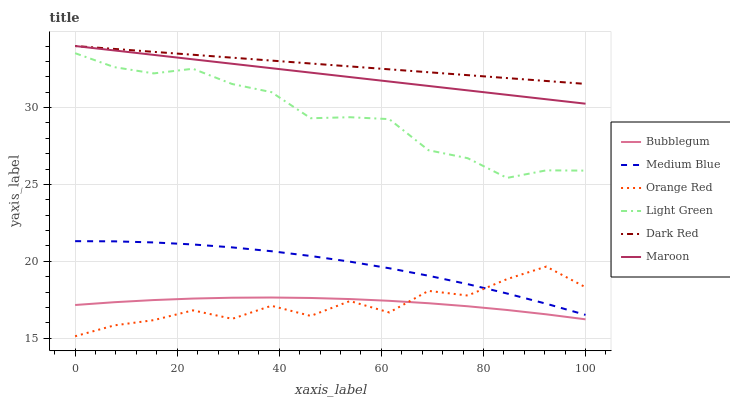Does Orange Red have the minimum area under the curve?
Answer yes or no. Yes. Does Dark Red have the maximum area under the curve?
Answer yes or no. Yes. Does Medium Blue have the minimum area under the curve?
Answer yes or no. No. Does Medium Blue have the maximum area under the curve?
Answer yes or no. No. Is Maroon the smoothest?
Answer yes or no. Yes. Is Orange Red the roughest?
Answer yes or no. Yes. Is Medium Blue the smoothest?
Answer yes or no. No. Is Medium Blue the roughest?
Answer yes or no. No. Does Orange Red have the lowest value?
Answer yes or no. Yes. Does Medium Blue have the lowest value?
Answer yes or no. No. Does Maroon have the highest value?
Answer yes or no. Yes. Does Medium Blue have the highest value?
Answer yes or no. No. Is Medium Blue less than Dark Red?
Answer yes or no. Yes. Is Medium Blue greater than Bubblegum?
Answer yes or no. Yes. Does Orange Red intersect Medium Blue?
Answer yes or no. Yes. Is Orange Red less than Medium Blue?
Answer yes or no. No. Is Orange Red greater than Medium Blue?
Answer yes or no. No. Does Medium Blue intersect Dark Red?
Answer yes or no. No. 